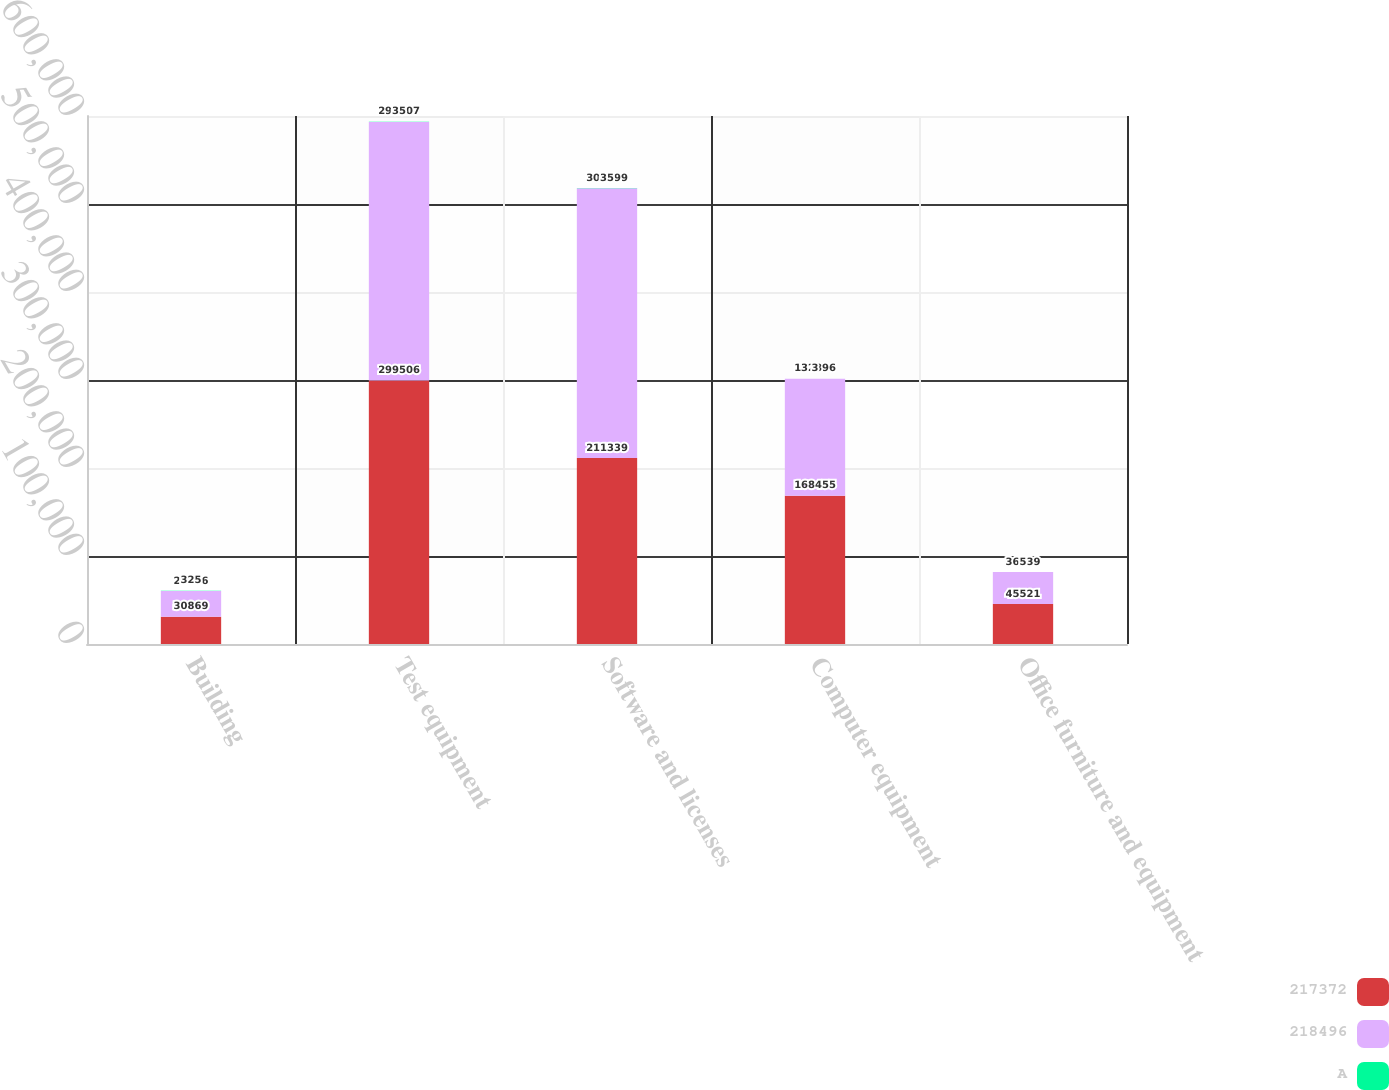<chart> <loc_0><loc_0><loc_500><loc_500><stacked_bar_chart><ecel><fcel>Building<fcel>Test equipment<fcel>Software and licenses<fcel>Computer equipment<fcel>Office furniture and equipment<nl><fcel>217372<fcel>30869<fcel>299506<fcel>211339<fcel>168455<fcel>45521<nl><fcel>218496<fcel>29326<fcel>293807<fcel>306699<fcel>132896<fcel>36239<nl><fcel>A<fcel>325<fcel>35<fcel>35<fcel>3<fcel>5<nl></chart> 